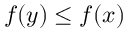<formula> <loc_0><loc_0><loc_500><loc_500>f ( y ) \leq f ( x )</formula> 